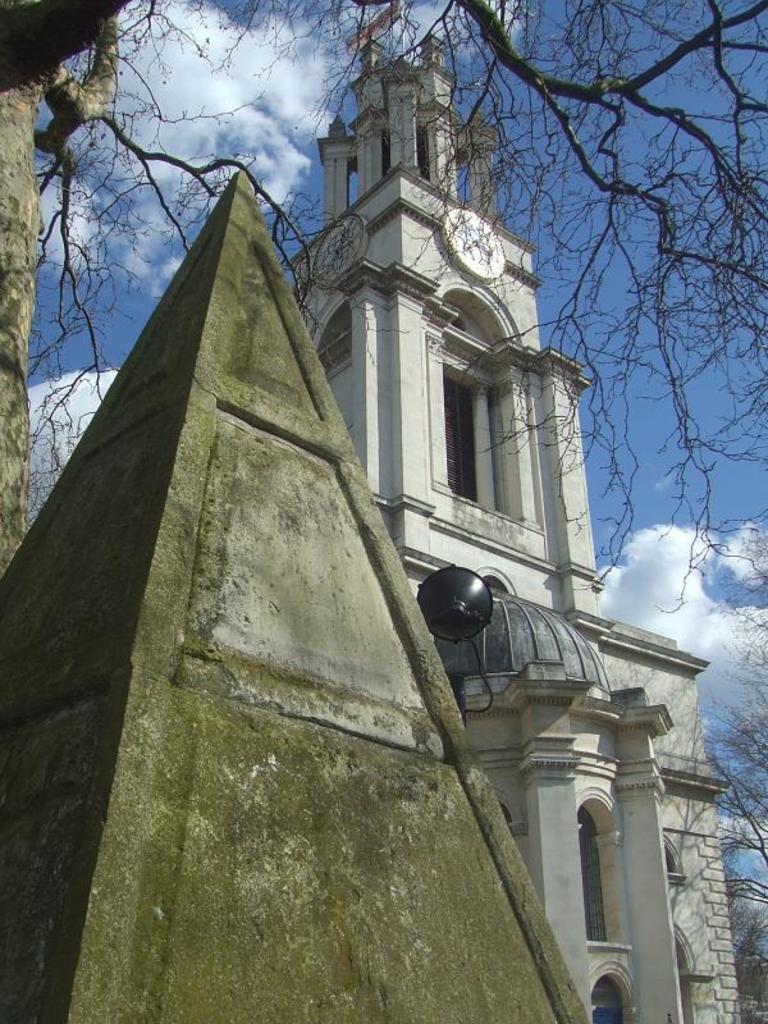What type of structure is present in the image? There is a building in the image. What other natural elements can be seen in the image? There are trees in the image. Where is the pyramid structure located in the image? The pyramid structure is on the left side of the image. What is visible in the background of the image? The sky is visible in the background of the image. Is there a property for sale sign near the pyramid structure in the image? There is no mention of a property for sale sign in the image, so it cannot be determined from the provided facts. Can you see a kite flying in the sky in the image? There is no mention of a kite in the image, so it cannot be determined from the provided facts. 